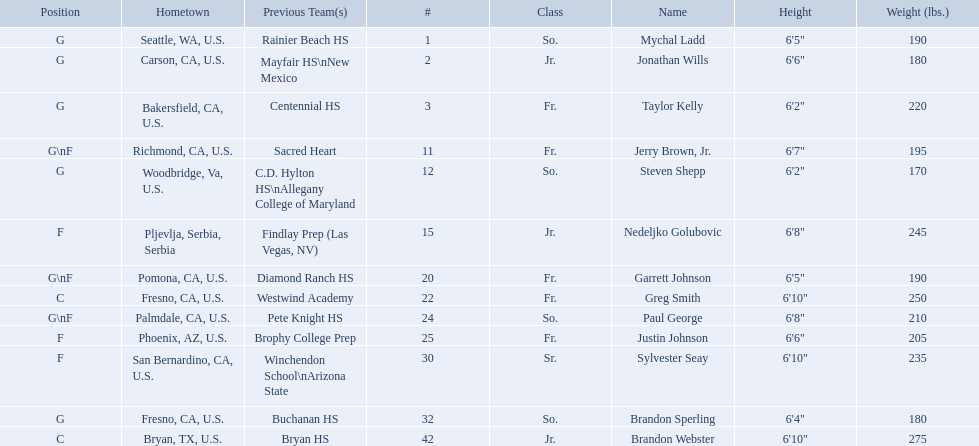Where were all of the players born? So., Jr., Fr., Fr., So., Jr., Fr., Fr., So., Fr., Sr., So., Jr. Who is the one from serbia? Nedeljko Golubovic. 